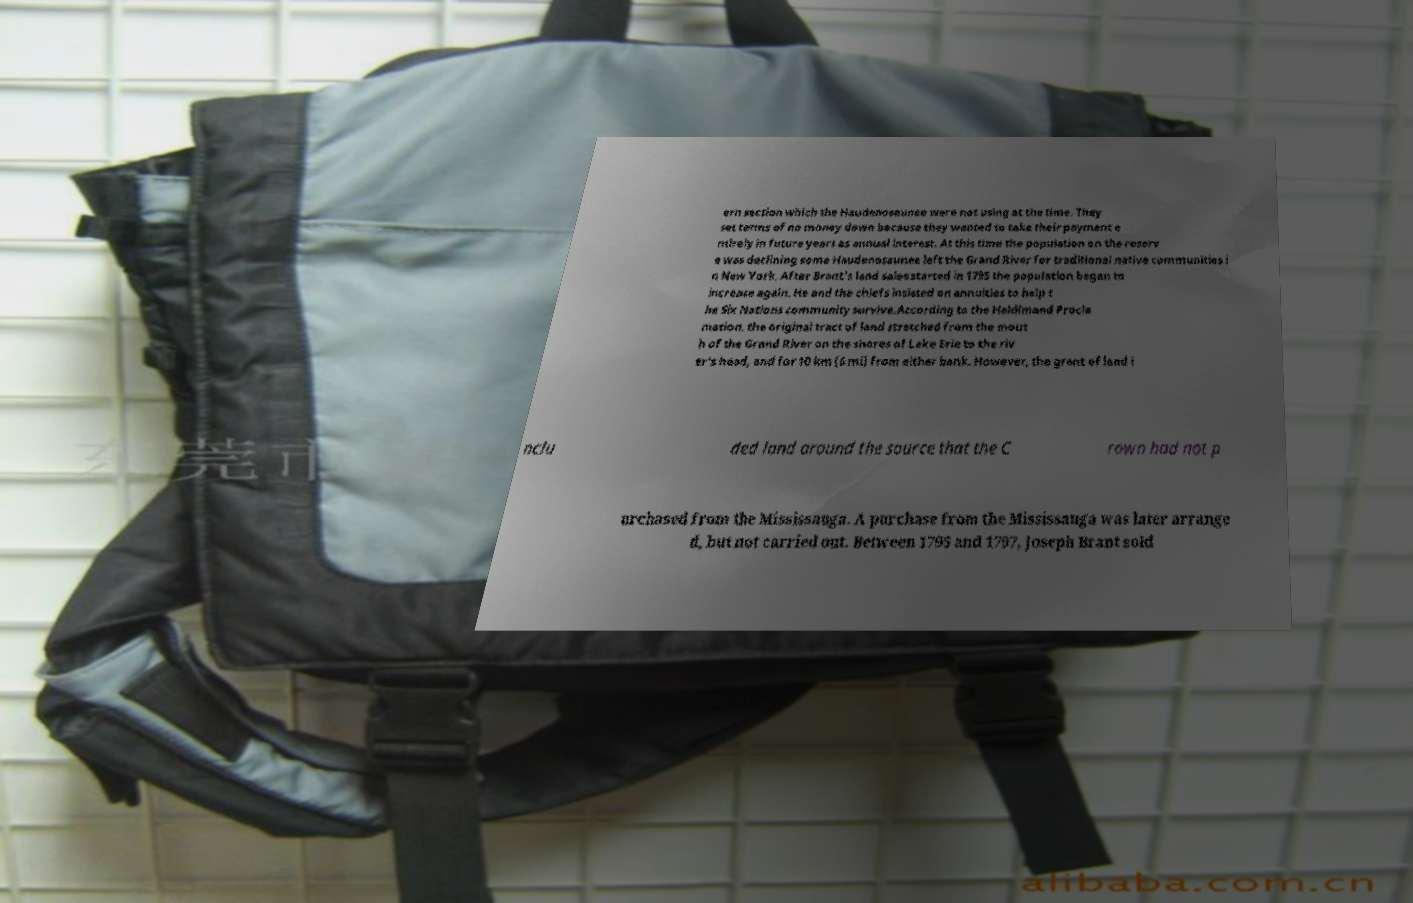Please read and relay the text visible in this image. What does it say? ern section which the Haudenosaunee were not using at the time. They set terms of no money down because they wanted to take their payment e ntirely in future years as annual interest. At this time the population on the reserv e was declining some Haudenosaunee left the Grand River for traditional native communities i n New York. After Brant's land sales started in 1795 the population began to increase again. He and the chiefs insisted on annuities to help t he Six Nations community survive.According to the Haldimand Procla mation, the original tract of land stretched from the mout h of the Grand River on the shores of Lake Erie to the riv er's head, and for 10 km (6 mi) from either bank. However, the grant of land i nclu ded land around the source that the C rown had not p urchased from the Mississauga. A purchase from the Mississauga was later arrange d, but not carried out. Between 1795 and 1797, Joseph Brant sold 